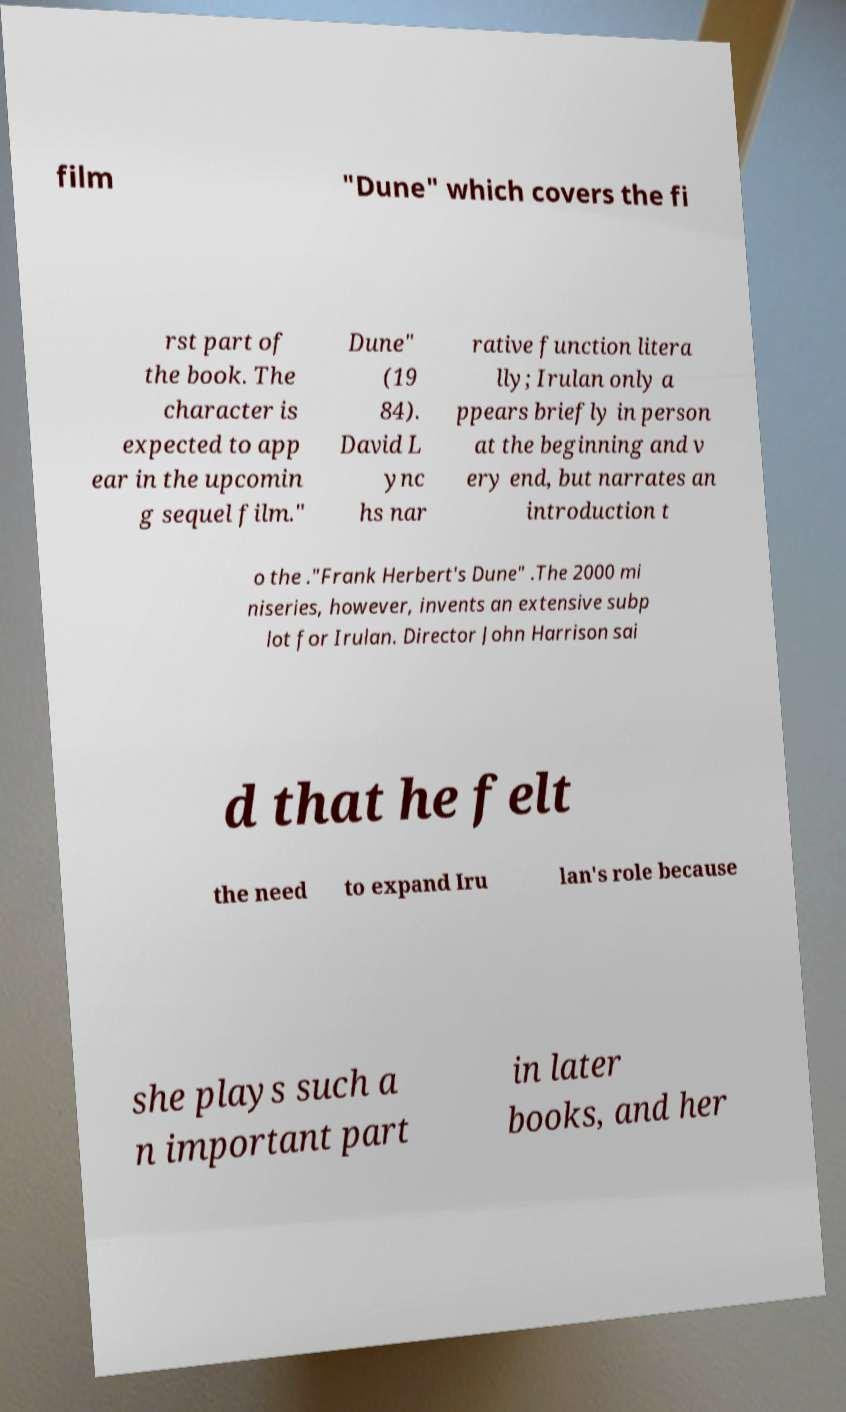Please identify and transcribe the text found in this image. film "Dune" which covers the fi rst part of the book. The character is expected to app ear in the upcomin g sequel film." Dune" (19 84). David L ync hs nar rative function litera lly; Irulan only a ppears briefly in person at the beginning and v ery end, but narrates an introduction t o the ."Frank Herbert's Dune" .The 2000 mi niseries, however, invents an extensive subp lot for Irulan. Director John Harrison sai d that he felt the need to expand Iru lan's role because she plays such a n important part in later books, and her 